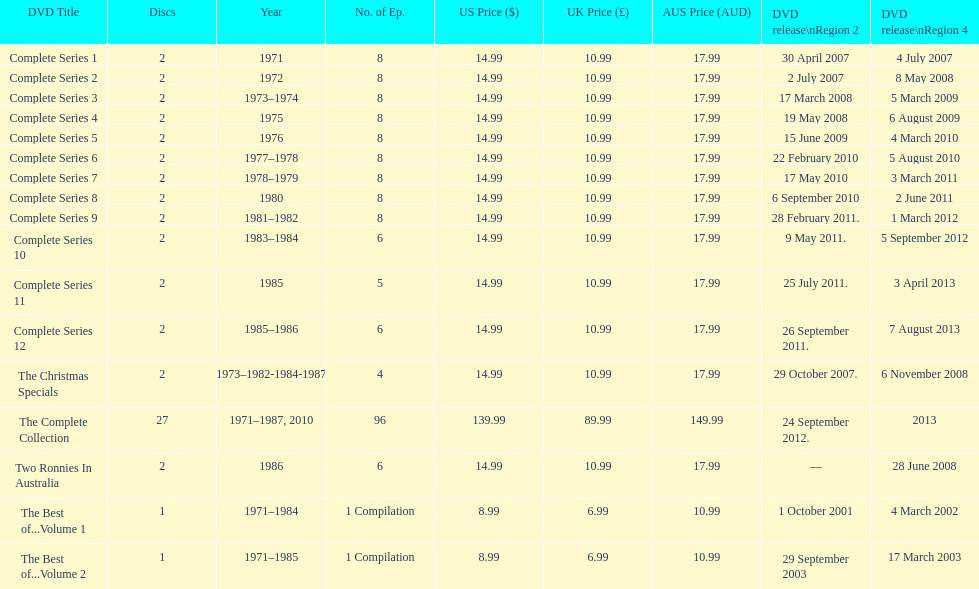Could you parse the entire table? {'header': ['DVD Title', 'Discs', 'Year', 'No. of Ep.', 'US Price ($)', 'UK Price (£)', 'AUS Price (AUD)', 'DVD release\\nRegion 2', 'DVD release\\nRegion 4'], 'rows': [['Complete Series 1', '2', '1971', '8', '14.99', '10.99', '17.99', '30 April 2007', '4 July 2007'], ['Complete Series 2', '2', '1972', '8', '14.99', '10.99', '17.99', '2 July 2007', '8 May 2008'], ['Complete Series 3', '2', '1973–1974', '8', '14.99', '10.99', '17.99', '17 March 2008', '5 March 2009'], ['Complete Series 4', '2', '1975', '8', '14.99', '10.99', '17.99', '19 May 2008', '6 August 2009'], ['Complete Series 5', '2', '1976', '8', '14.99', '10.99', '17.99', '15 June 2009', '4 March 2010'], ['Complete Series 6', '2', '1977–1978', '8', '14.99', '10.99', '17.99', '22 February 2010', '5 August 2010'], ['Complete Series 7', '2', '1978–1979', '8', '14.99', '10.99', '17.99', '17 May 2010', '3 March 2011'], ['Complete Series 8', '2', '1980', '8', '14.99', '10.99', '17.99', '6 September 2010', '2 June 2011'], ['Complete Series 9', '2', '1981–1982', '8', '14.99', '10.99', '17.99', '28 February 2011.', '1 March 2012'], ['Complete Series 10', '2', '1983–1984', '6', '14.99', '10.99', '17.99', '9 May 2011.', '5 September 2012'], ['Complete Series 11', '2', '1985', '5', '14.99', '10.99', '17.99', '25 July 2011.', '3 April 2013'], ['Complete Series 12', '2', '1985–1986', '6', '14.99', '10.99', '17.99', '26 September 2011.', '7 August 2013'], ['The Christmas Specials', '2', '1973–1982-1984-1987', '4', '14.99', '10.99', '17.99', '29 October 2007.', '6 November 2008'], ['The Complete Collection', '27', '1971–1987, 2010', '96', '139.99', '89.99', '149.99', '24 September 2012.', '2013'], ['Two Ronnies In Australia', '2', '1986', '6', '14.99', '10.99', '17.99', '—', '28 June 2008'], ['The Best of...Volume 1', '1', '1971–1984', '1 Compilation', '8.99', '6.99', '10.99', '1 October 2001', '4 March 2002'], ['The Best of...Volume 2', '1', '1971–1985', '1 Compilation', '8.99', '6.99', '10.99', '29 September 2003', '17 March 2003']]} True or false. the television show "the two ronnies" featured more than 10 episodes in a season. False. 